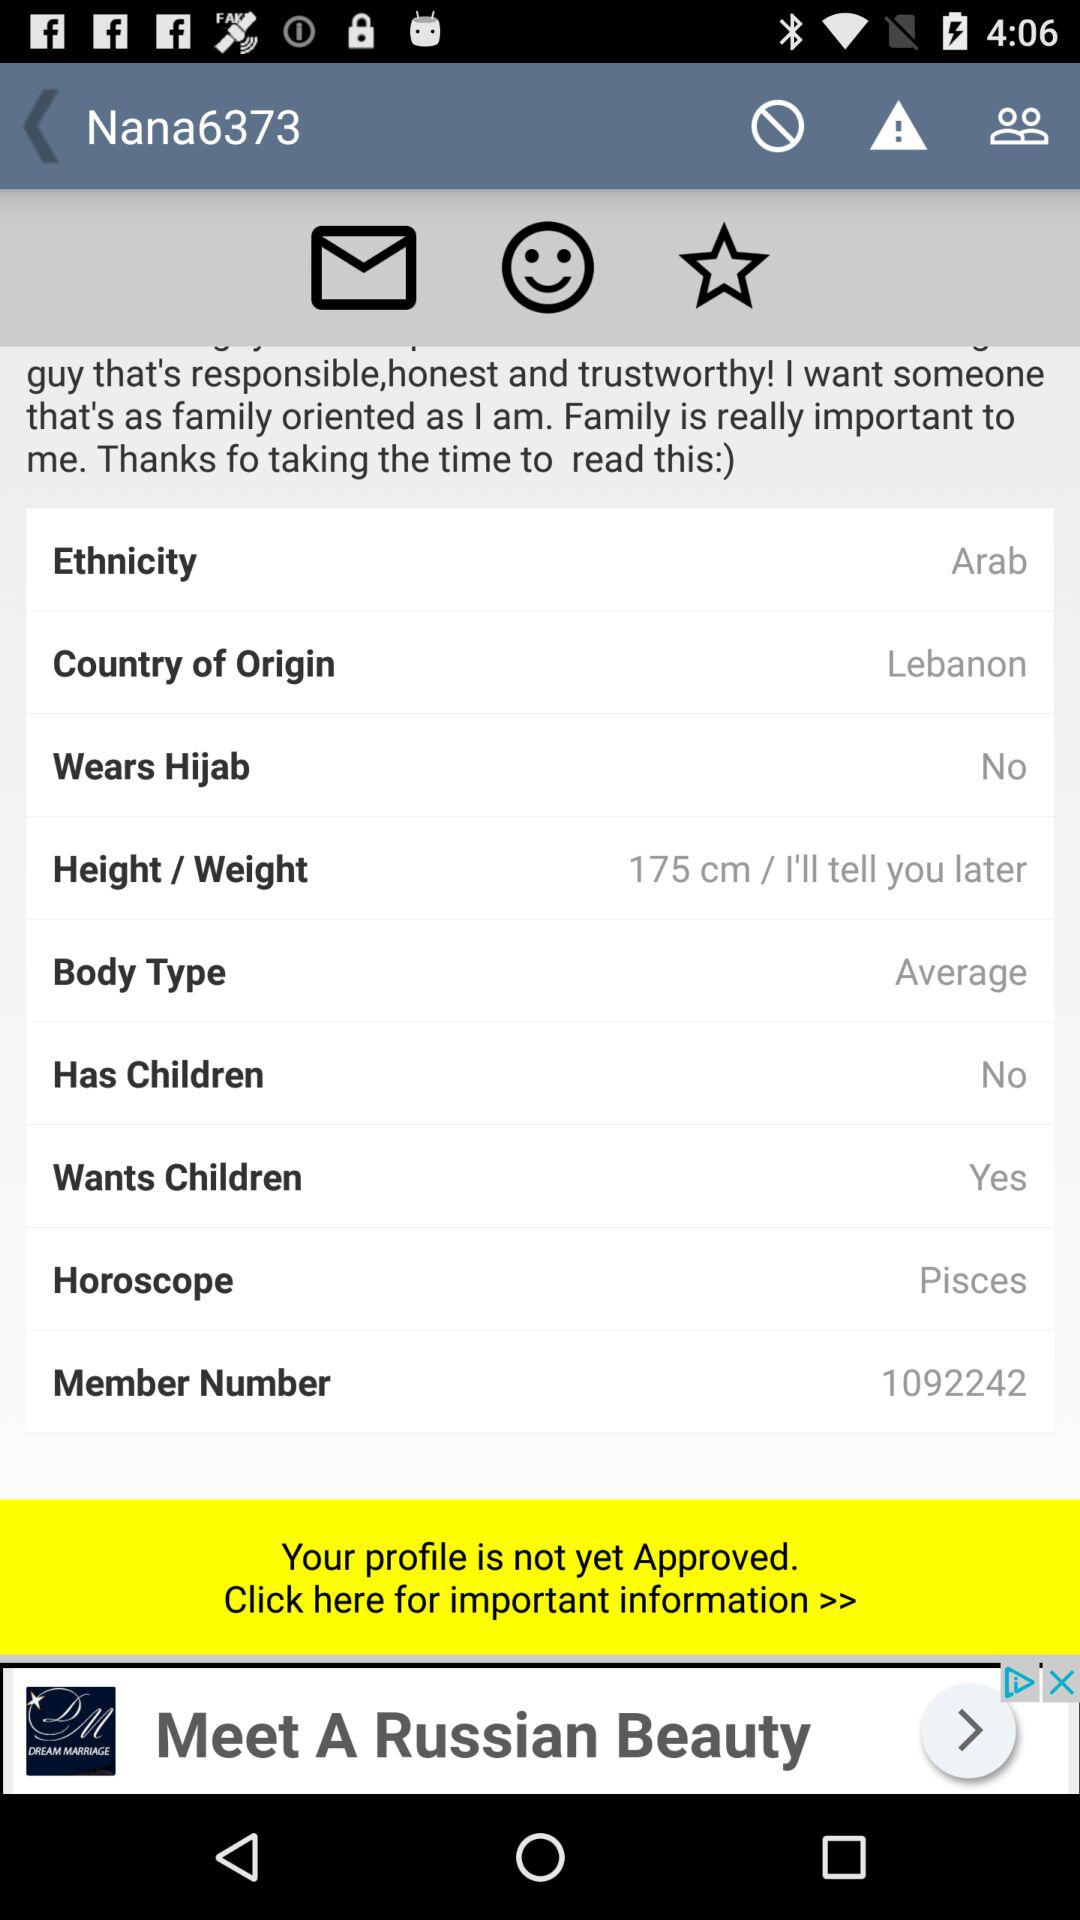What is the username? The username is "Nana6373". 